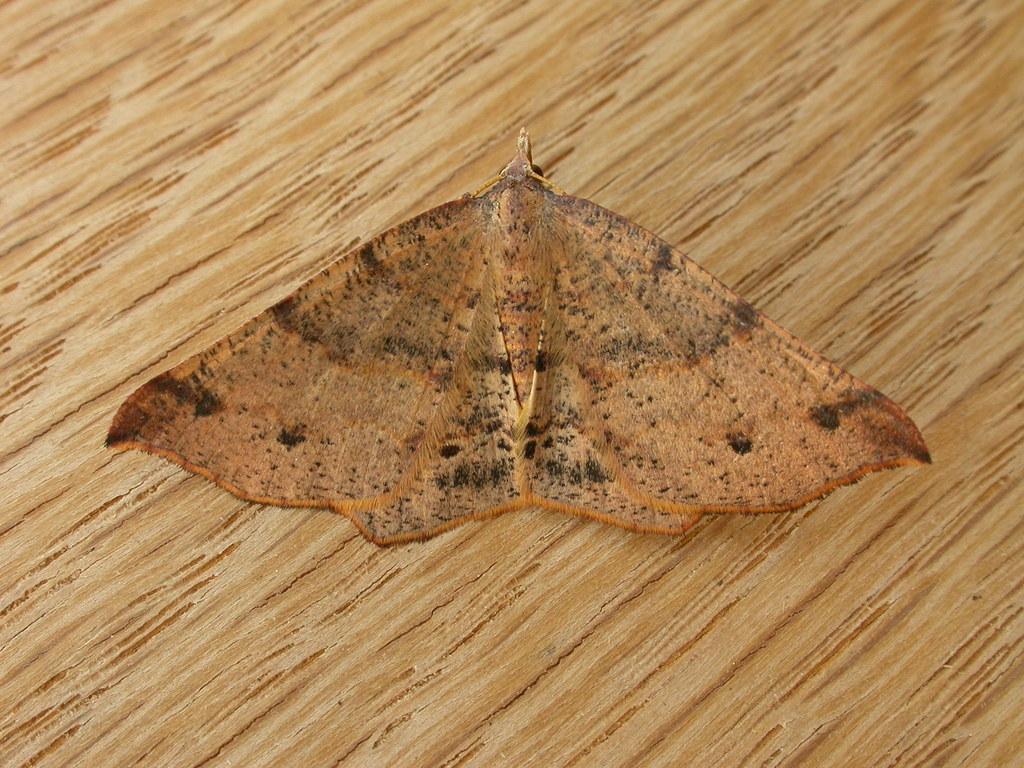Describe this image in one or two sentences. In the middle of the image there is a butterfly on the wooden surface. 